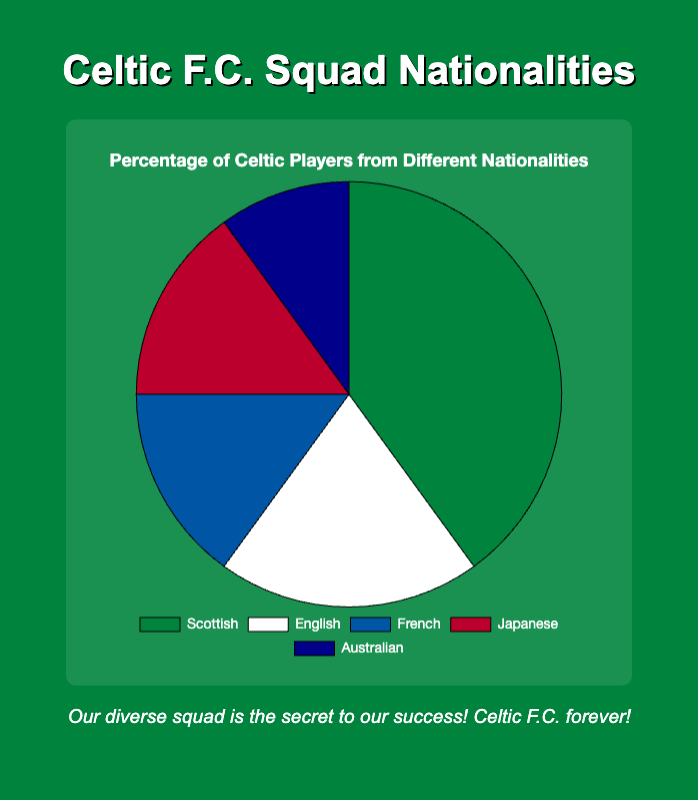What's the most common nationality among Celtic players? The data shows the percentage of Celtic players from different nationalities. The nationality with the highest percentage is the most common. The Scottish players constitute 40% of the team, which is the highest.
Answer: Scottish Which two nationalities have equal representation in the squad? Reviewing the chart, we can see that the French and Japanese players both represent 15% of the squad.
Answer: French and Japanese What is the total percentage of players that are either French or Australian? Summing up the percentages of French (15%) and Australian (10%) players gives us the total percentage. 15% + 10% = 25%.
Answer: 25% Which nationality has double the representation compared to Australian players? The Australian players form 10% of the squad. When we double this percentage (10% * 2 = 20%), we ascertain that the percentage matches the English players.
Answer: English What percentage of the squad consists of non-Scottish players? The Scottish players make up 40% of the team. Therefore, the percentage of non-Scottish players is 100% - 40% = 60%.
Answer: 60% Among the listed nationalities, which one has the least representation? The chart shows the smallest percentage among the nationalities. The Australian players form the smallest group with 10%.
Answer: Australian How many nationalities together form more than half of the squad? We need to find the smallest combination of nationalities whose combined percentage exceeds 50%. Starting with the largest percentage:
- Scottish (40%) + English (20%) = 60%, which is more than 50%.
Thus, just the Scottish and English players together form more than half of the squad.
Answer: Two If 5 more Scottish players joined the squad, increasing their share by 10%, what would the new percentage of Scottish players be? The current percentage of Scottish players is 40%. Adding 10% more makes it 40% + 10% = 50%.
Answer: 50% What is the difference in representation between the Japanese and English players? The Japanese players form 15% of the squad, while the English players form 20%. The difference between them is 20% - 15% = 5%.
Answer: 5% If the total squad size is 50 players, how many players are French? The French players represent 15% of the squad. If there are 50 players in total, the number of French players is 15% of 50. 0.15 * 50 = 7.5, approximately 8 players (as the count must be an integer).
Answer: 8 